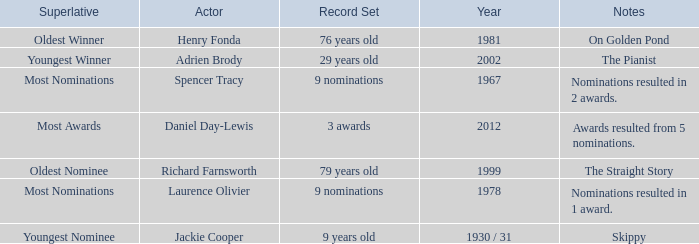What year was the the youngest nominee a winner? 1930 / 31. Help me parse the entirety of this table. {'header': ['Superlative', 'Actor', 'Record Set', 'Year', 'Notes'], 'rows': [['Oldest Winner', 'Henry Fonda', '76 years old', '1981', 'On Golden Pond'], ['Youngest Winner', 'Adrien Brody', '29 years old', '2002', 'The Pianist'], ['Most Nominations', 'Spencer Tracy', '9 nominations', '1967', 'Nominations resulted in 2 awards.'], ['Most Awards', 'Daniel Day-Lewis', '3 awards', '2012', 'Awards resulted from 5 nominations.'], ['Oldest Nominee', 'Richard Farnsworth', '79 years old', '1999', 'The Straight Story'], ['Most Nominations', 'Laurence Olivier', '9 nominations', '1978', 'Nominations resulted in 1 award.'], ['Youngest Nominee', 'Jackie Cooper', '9 years old', '1930 / 31', 'Skippy']]} 